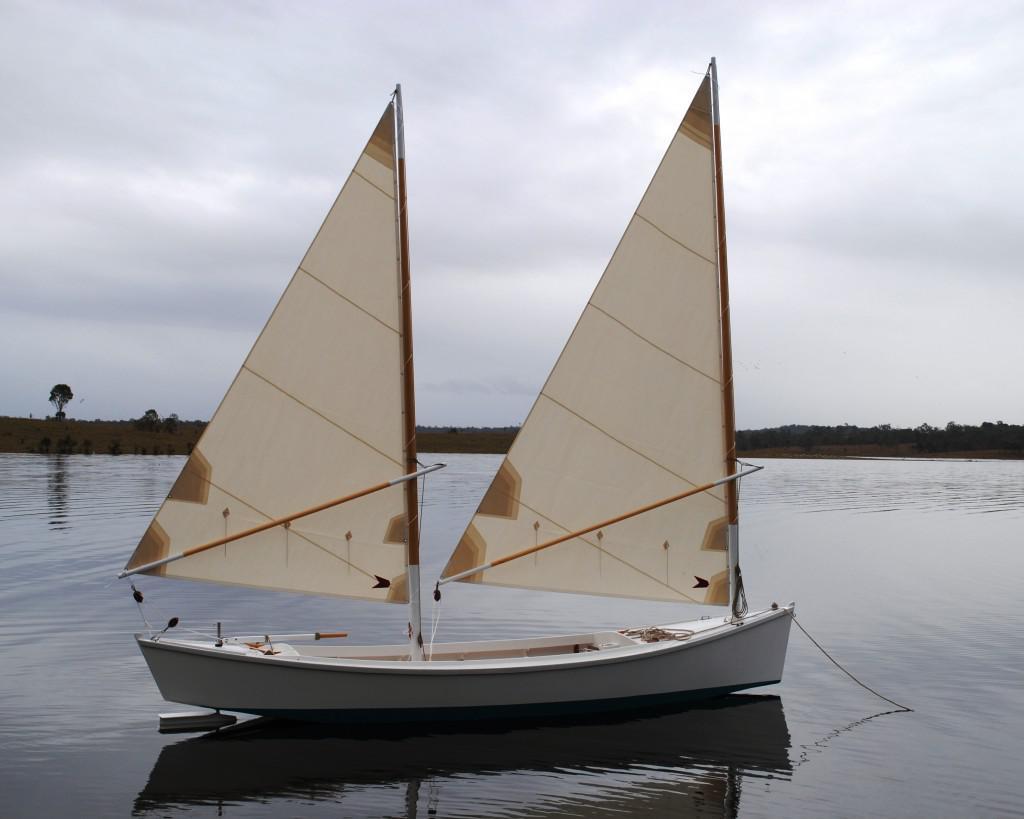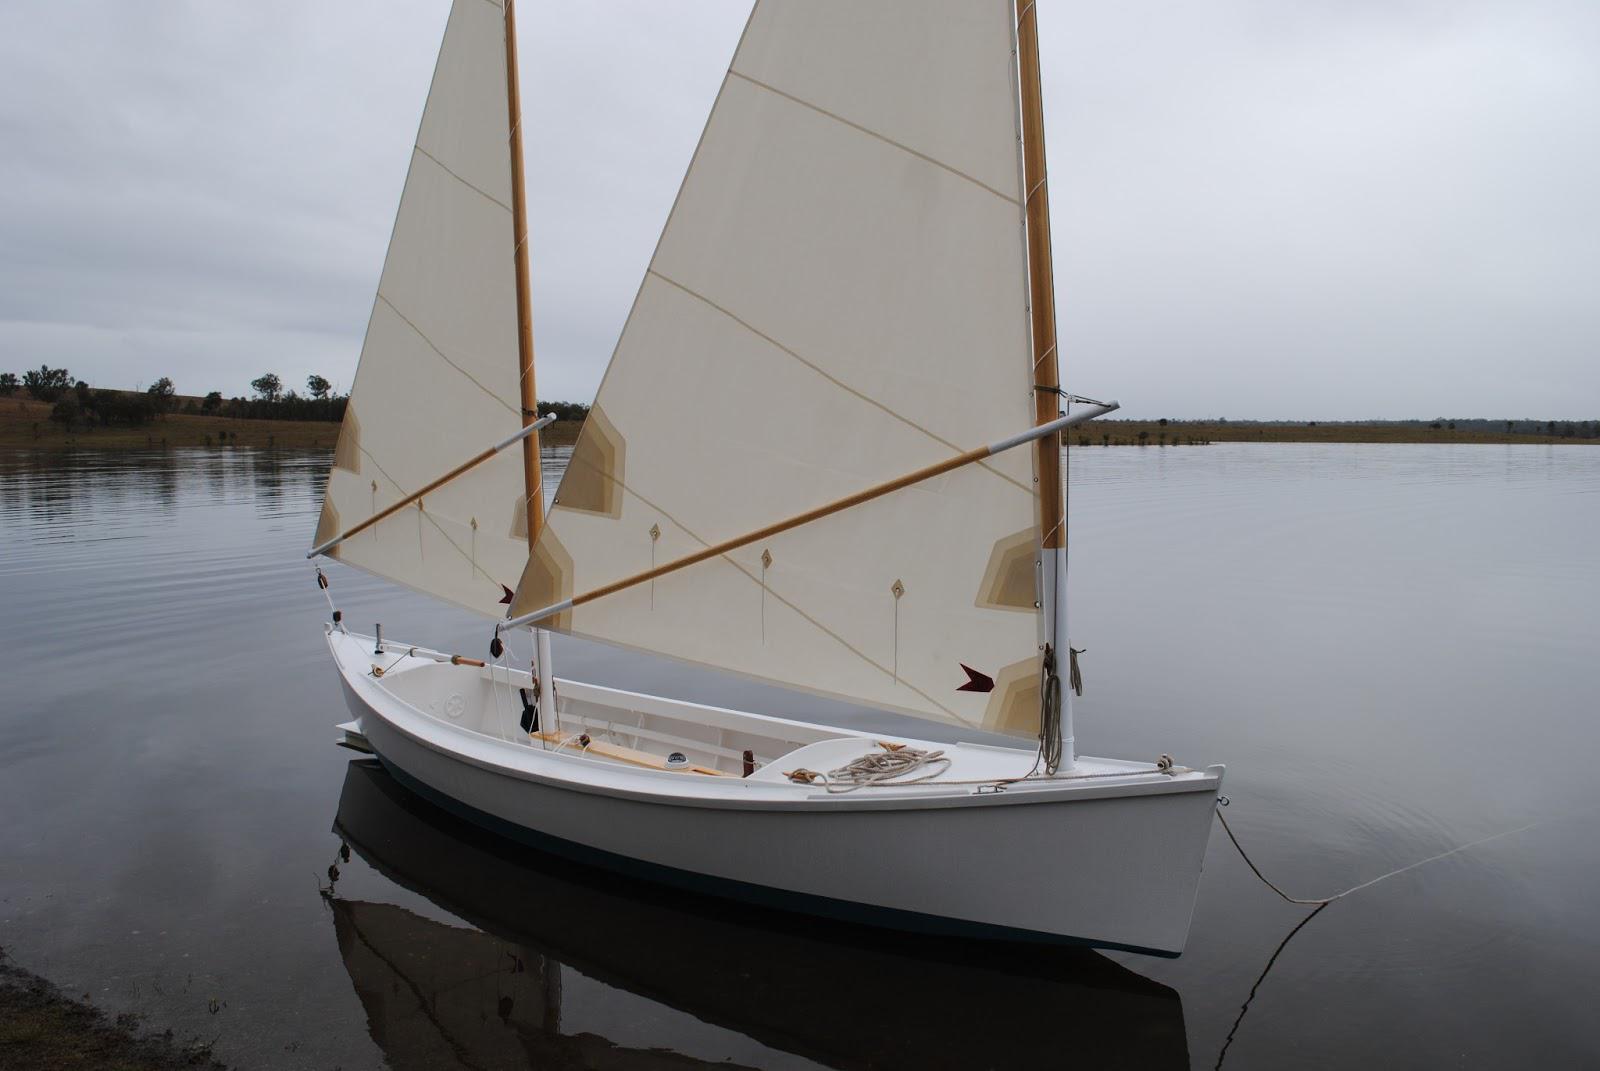The first image is the image on the left, the second image is the image on the right. Considering the images on both sides, is "Each sailboat has two white sails." valid? Answer yes or no. Yes. The first image is the image on the left, the second image is the image on the right. Analyze the images presented: Is the assertion "the image pair has a boat with two raised sails" valid? Answer yes or no. Yes. 